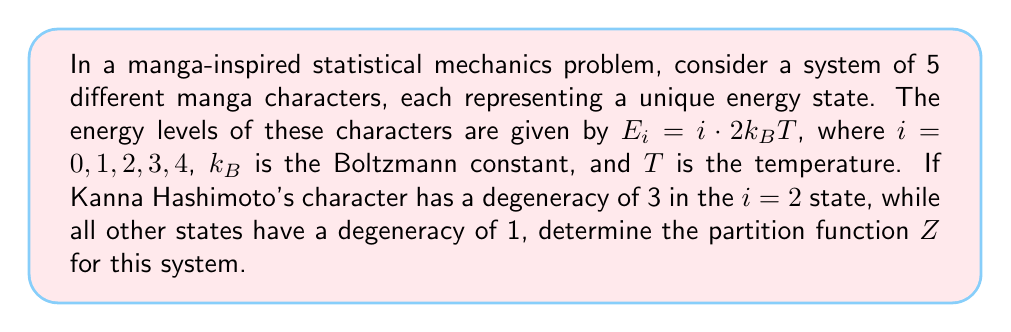Show me your answer to this math problem. To solve this problem, we'll follow these steps:

1) Recall that the partition function $Z$ is given by:

   $$Z = \sum_i g_i e^{-\beta E_i}$$

   where $g_i$ is the degeneracy of state $i$, $\beta = \frac{1}{k_BT}$, and $E_i$ is the energy of state $i$.

2) In this case, $E_i = i \cdot 2k_BT$, so $\beta E_i = i \cdot 2k_BT \cdot \frac{1}{k_BT} = 2i$.

3) Let's calculate the term for each state:

   For $i = 0$: $g_0 e^{-\beta E_0} = 1 \cdot e^{-2 \cdot 0} = 1$
   For $i = 1$: $g_1 e^{-\beta E_1} = 1 \cdot e^{-2 \cdot 1} = e^{-2}$
   For $i = 2$: $g_2 e^{-\beta E_2} = 3 \cdot e^{-2 \cdot 2} = 3e^{-4}$ (Kanna's state)
   For $i = 3$: $g_3 e^{-\beta E_3} = 1 \cdot e^{-2 \cdot 3} = e^{-6}$
   For $i = 4$: $g_4 e^{-\beta E_4} = 1 \cdot e^{-2 \cdot 4} = e^{-8}$

4) Now, we sum all these terms:

   $$Z = 1 + e^{-2} + 3e^{-4} + e^{-6} + e^{-8}$$

This is the partition function for the given system.
Answer: $Z = 1 + e^{-2} + 3e^{-4} + e^{-6} + e^{-8}$ 